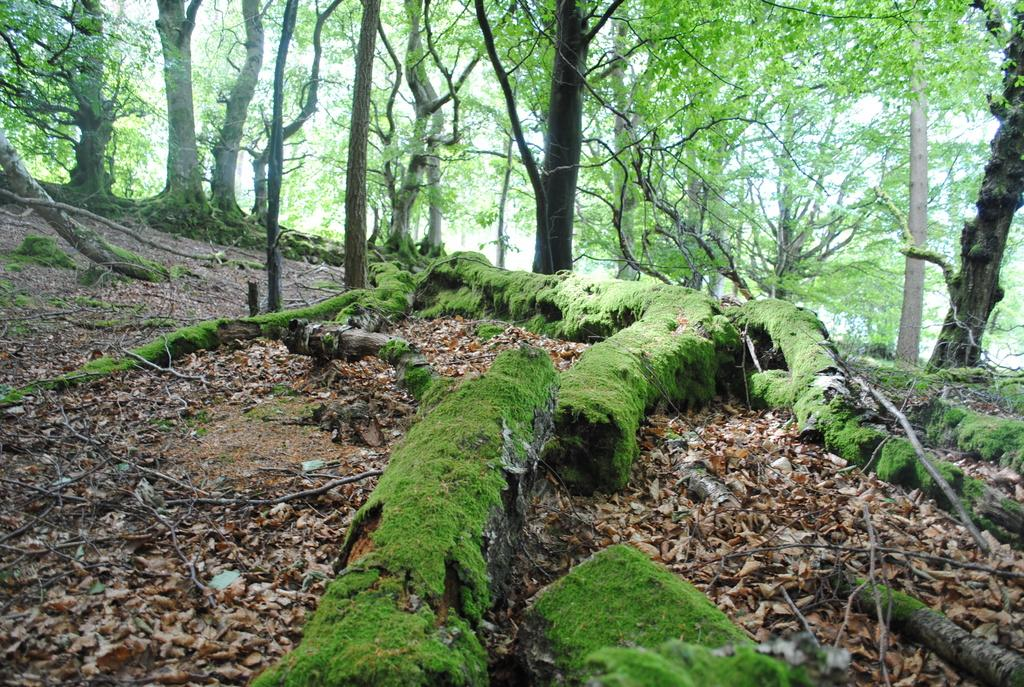What type of vegetation is present in the image? There are many trees in the image. What type of ground surface can be seen in the image? There is sand in the image. What else can be found on the ground in the image? There are dried leaves in the image. What is the condition of the branches in the image? The branches are covered with grass in the image. What is visible in the background of the image? The sky is visible in the image. How does the boot help the person in the image? There is: There is no boot present in the image. 